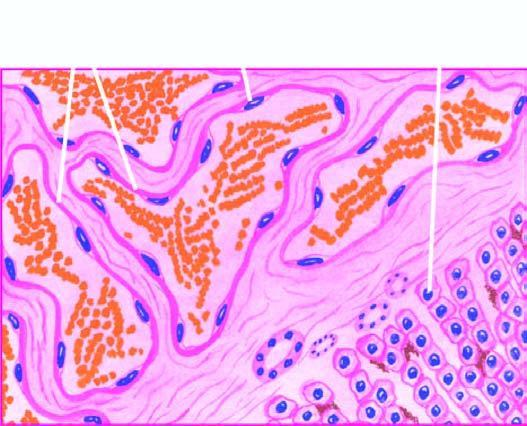what is scanty connective tissue stroma seen between?
Answer the question using a single word or phrase. The cavernous spaces 